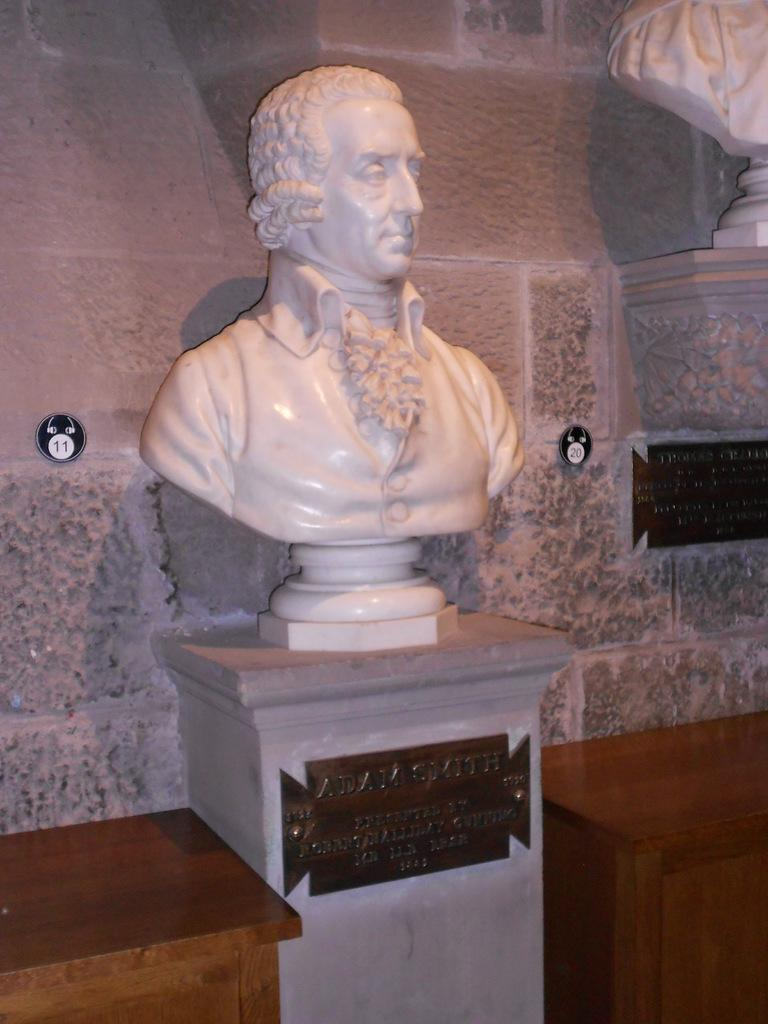What is the main subject of the image? There is a statue of a man in the image. Where is the image set? The image is set in a basement. What color is the crayon that the dog is holding in the image? There is no crayon or dog present in the image; it features a statue of a man in a basement. 